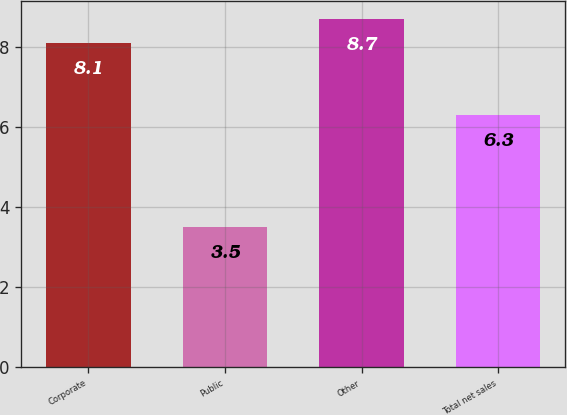Convert chart to OTSL. <chart><loc_0><loc_0><loc_500><loc_500><bar_chart><fcel>Corporate<fcel>Public<fcel>Other<fcel>Total net sales<nl><fcel>8.1<fcel>3.5<fcel>8.7<fcel>6.3<nl></chart> 